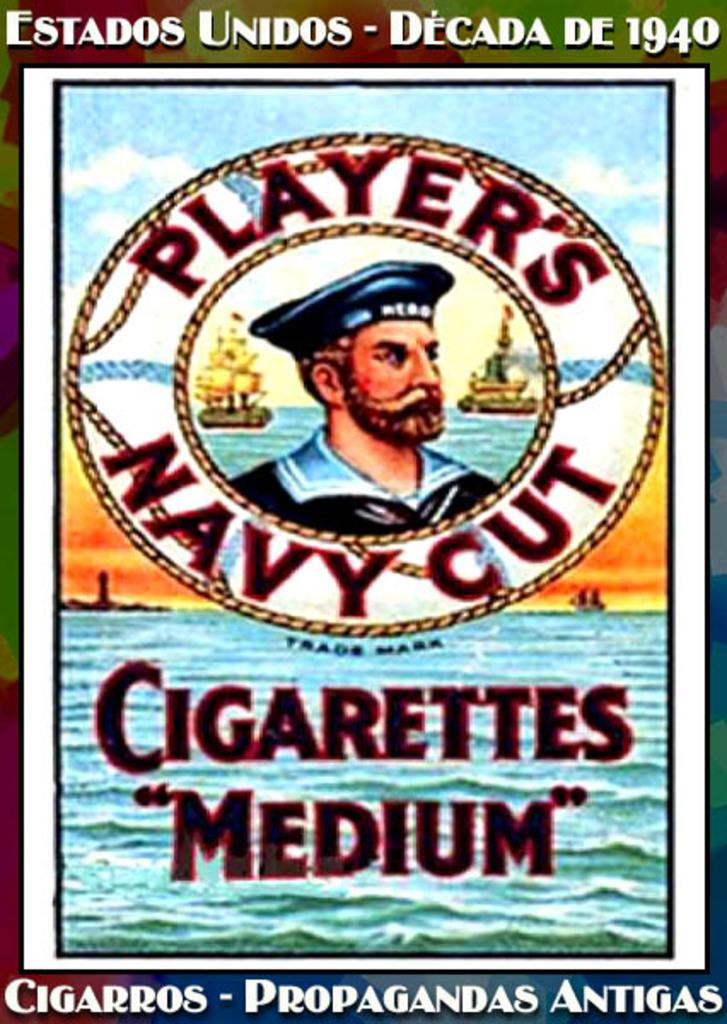Provide a one-sentence caption for the provided image. a poster of Players Navy Cut Cigarettes with a man in the middle. 